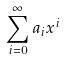Convert formula to latex. <formula><loc_0><loc_0><loc_500><loc_500>\sum _ { i = 0 } ^ { \infty } a _ { i } x ^ { i }</formula> 